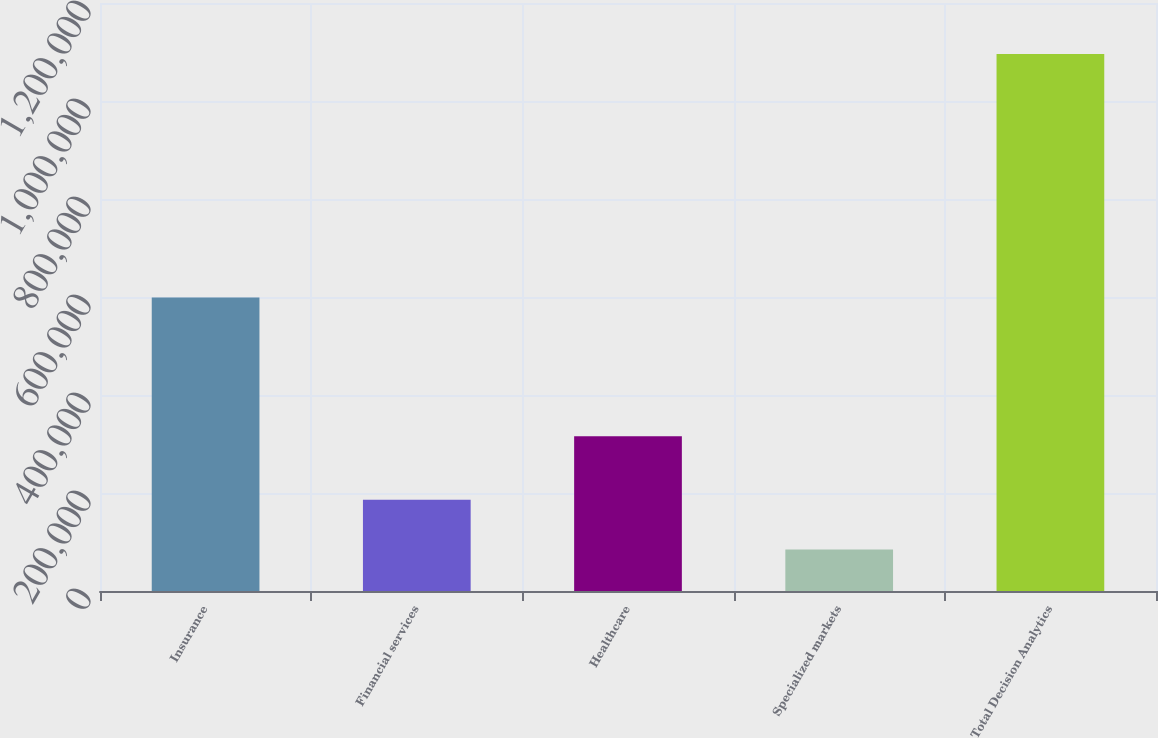<chart> <loc_0><loc_0><loc_500><loc_500><bar_chart><fcel>Insurance<fcel>Financial services<fcel>Healthcare<fcel>Specialized markets<fcel>Total Decision Analytics<nl><fcel>598757<fcel>186041<fcel>315628<fcel>84926<fcel>1.09607e+06<nl></chart> 